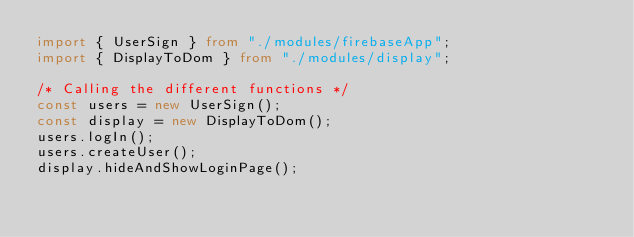<code> <loc_0><loc_0><loc_500><loc_500><_TypeScript_>import { UserSign } from "./modules/firebaseApp";
import { DisplayToDom } from "./modules/display";

/* Calling the different functions */
const users = new UserSign();
const display = new DisplayToDom();
users.logIn();
users.createUser();
display.hideAndShowLoginPage();</code> 